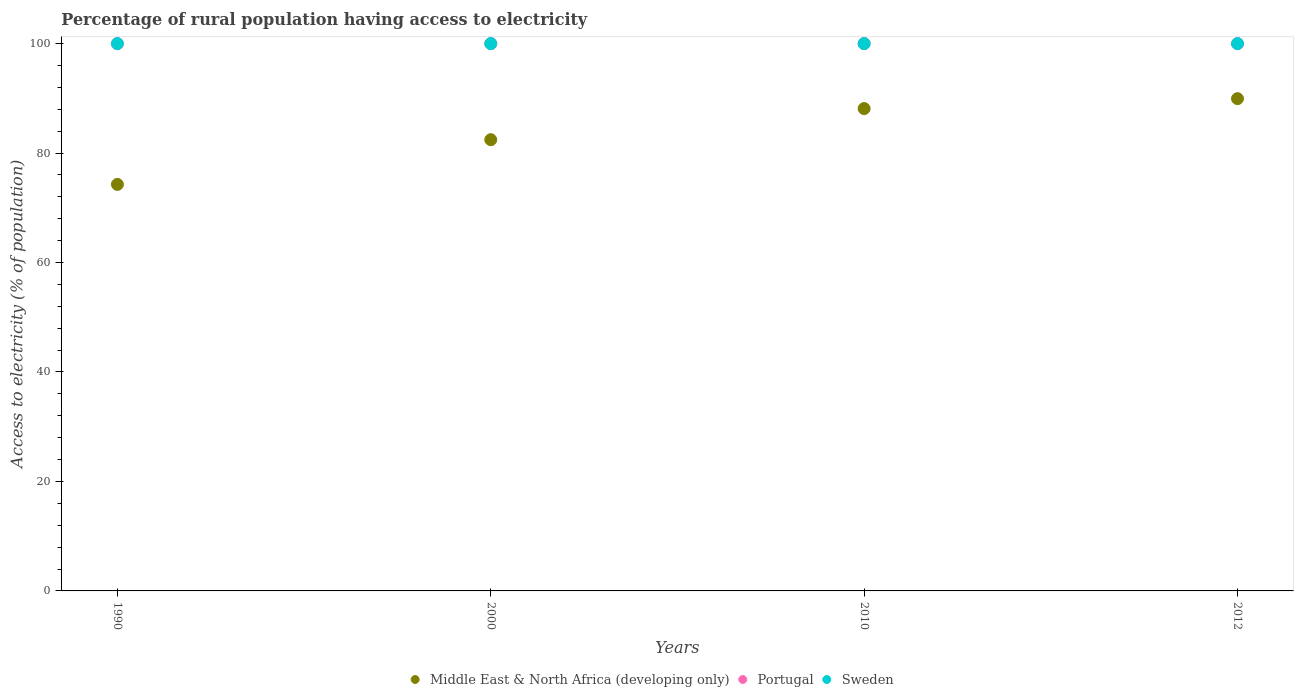Is the number of dotlines equal to the number of legend labels?
Offer a terse response. Yes. What is the percentage of rural population having access to electricity in Portugal in 1990?
Your response must be concise. 100. Across all years, what is the maximum percentage of rural population having access to electricity in Middle East & North Africa (developing only)?
Provide a short and direct response. 89.94. Across all years, what is the minimum percentage of rural population having access to electricity in Sweden?
Provide a short and direct response. 100. In which year was the percentage of rural population having access to electricity in Sweden maximum?
Keep it short and to the point. 1990. In which year was the percentage of rural population having access to electricity in Sweden minimum?
Your answer should be compact. 1990. What is the total percentage of rural population having access to electricity in Sweden in the graph?
Provide a succinct answer. 400. What is the difference between the percentage of rural population having access to electricity in Middle East & North Africa (developing only) in 2000 and that in 2010?
Offer a very short reply. -5.68. What is the difference between the percentage of rural population having access to electricity in Middle East & North Africa (developing only) in 2000 and the percentage of rural population having access to electricity in Portugal in 1990?
Provide a short and direct response. -17.55. In the year 2010, what is the difference between the percentage of rural population having access to electricity in Sweden and percentage of rural population having access to electricity in Portugal?
Provide a succinct answer. 0. In how many years, is the percentage of rural population having access to electricity in Middle East & North Africa (developing only) greater than 48 %?
Your response must be concise. 4. What is the ratio of the percentage of rural population having access to electricity in Portugal in 2000 to that in 2010?
Your response must be concise. 1. Is the percentage of rural population having access to electricity in Middle East & North Africa (developing only) in 2010 less than that in 2012?
Your answer should be compact. Yes. Is the difference between the percentage of rural population having access to electricity in Sweden in 1990 and 2000 greater than the difference between the percentage of rural population having access to electricity in Portugal in 1990 and 2000?
Offer a very short reply. No. What is the difference between the highest and the lowest percentage of rural population having access to electricity in Portugal?
Your answer should be compact. 0. In how many years, is the percentage of rural population having access to electricity in Sweden greater than the average percentage of rural population having access to electricity in Sweden taken over all years?
Offer a very short reply. 0. Is it the case that in every year, the sum of the percentage of rural population having access to electricity in Sweden and percentage of rural population having access to electricity in Middle East & North Africa (developing only)  is greater than the percentage of rural population having access to electricity in Portugal?
Your response must be concise. Yes. Does the percentage of rural population having access to electricity in Sweden monotonically increase over the years?
Keep it short and to the point. No. Is the percentage of rural population having access to electricity in Portugal strictly less than the percentage of rural population having access to electricity in Sweden over the years?
Give a very brief answer. No. What is the difference between two consecutive major ticks on the Y-axis?
Your response must be concise. 20. Does the graph contain grids?
Make the answer very short. No. How many legend labels are there?
Make the answer very short. 3. How are the legend labels stacked?
Your answer should be very brief. Horizontal. What is the title of the graph?
Offer a terse response. Percentage of rural population having access to electricity. What is the label or title of the X-axis?
Keep it short and to the point. Years. What is the label or title of the Y-axis?
Give a very brief answer. Access to electricity (% of population). What is the Access to electricity (% of population) in Middle East & North Africa (developing only) in 1990?
Keep it short and to the point. 74.28. What is the Access to electricity (% of population) of Middle East & North Africa (developing only) in 2000?
Make the answer very short. 82.45. What is the Access to electricity (% of population) of Portugal in 2000?
Keep it short and to the point. 100. What is the Access to electricity (% of population) of Sweden in 2000?
Your answer should be compact. 100. What is the Access to electricity (% of population) of Middle East & North Africa (developing only) in 2010?
Offer a terse response. 88.13. What is the Access to electricity (% of population) of Sweden in 2010?
Your answer should be compact. 100. What is the Access to electricity (% of population) in Middle East & North Africa (developing only) in 2012?
Provide a short and direct response. 89.94. What is the Access to electricity (% of population) in Portugal in 2012?
Your response must be concise. 100. What is the Access to electricity (% of population) in Sweden in 2012?
Offer a very short reply. 100. Across all years, what is the maximum Access to electricity (% of population) in Middle East & North Africa (developing only)?
Provide a succinct answer. 89.94. Across all years, what is the maximum Access to electricity (% of population) in Portugal?
Keep it short and to the point. 100. Across all years, what is the maximum Access to electricity (% of population) of Sweden?
Ensure brevity in your answer.  100. Across all years, what is the minimum Access to electricity (% of population) of Middle East & North Africa (developing only)?
Offer a very short reply. 74.28. Across all years, what is the minimum Access to electricity (% of population) of Sweden?
Ensure brevity in your answer.  100. What is the total Access to electricity (% of population) in Middle East & North Africa (developing only) in the graph?
Your answer should be compact. 334.8. What is the difference between the Access to electricity (% of population) of Middle East & North Africa (developing only) in 1990 and that in 2000?
Ensure brevity in your answer.  -8.17. What is the difference between the Access to electricity (% of population) in Portugal in 1990 and that in 2000?
Your answer should be compact. 0. What is the difference between the Access to electricity (% of population) in Middle East & North Africa (developing only) in 1990 and that in 2010?
Keep it short and to the point. -13.86. What is the difference between the Access to electricity (% of population) in Middle East & North Africa (developing only) in 1990 and that in 2012?
Provide a short and direct response. -15.67. What is the difference between the Access to electricity (% of population) in Middle East & North Africa (developing only) in 2000 and that in 2010?
Provide a succinct answer. -5.68. What is the difference between the Access to electricity (% of population) of Portugal in 2000 and that in 2010?
Provide a short and direct response. 0. What is the difference between the Access to electricity (% of population) in Middle East & North Africa (developing only) in 2000 and that in 2012?
Your answer should be very brief. -7.5. What is the difference between the Access to electricity (% of population) in Portugal in 2000 and that in 2012?
Offer a very short reply. 0. What is the difference between the Access to electricity (% of population) in Middle East & North Africa (developing only) in 2010 and that in 2012?
Offer a very short reply. -1.81. What is the difference between the Access to electricity (% of population) of Sweden in 2010 and that in 2012?
Provide a succinct answer. 0. What is the difference between the Access to electricity (% of population) of Middle East & North Africa (developing only) in 1990 and the Access to electricity (% of population) of Portugal in 2000?
Offer a very short reply. -25.72. What is the difference between the Access to electricity (% of population) in Middle East & North Africa (developing only) in 1990 and the Access to electricity (% of population) in Sweden in 2000?
Provide a succinct answer. -25.72. What is the difference between the Access to electricity (% of population) in Middle East & North Africa (developing only) in 1990 and the Access to electricity (% of population) in Portugal in 2010?
Offer a terse response. -25.72. What is the difference between the Access to electricity (% of population) in Middle East & North Africa (developing only) in 1990 and the Access to electricity (% of population) in Sweden in 2010?
Provide a short and direct response. -25.72. What is the difference between the Access to electricity (% of population) of Middle East & North Africa (developing only) in 1990 and the Access to electricity (% of population) of Portugal in 2012?
Provide a short and direct response. -25.72. What is the difference between the Access to electricity (% of population) of Middle East & North Africa (developing only) in 1990 and the Access to electricity (% of population) of Sweden in 2012?
Offer a very short reply. -25.72. What is the difference between the Access to electricity (% of population) of Portugal in 1990 and the Access to electricity (% of population) of Sweden in 2012?
Offer a very short reply. 0. What is the difference between the Access to electricity (% of population) of Middle East & North Africa (developing only) in 2000 and the Access to electricity (% of population) of Portugal in 2010?
Give a very brief answer. -17.55. What is the difference between the Access to electricity (% of population) of Middle East & North Africa (developing only) in 2000 and the Access to electricity (% of population) of Sweden in 2010?
Provide a succinct answer. -17.55. What is the difference between the Access to electricity (% of population) in Portugal in 2000 and the Access to electricity (% of population) in Sweden in 2010?
Your response must be concise. 0. What is the difference between the Access to electricity (% of population) in Middle East & North Africa (developing only) in 2000 and the Access to electricity (% of population) in Portugal in 2012?
Make the answer very short. -17.55. What is the difference between the Access to electricity (% of population) in Middle East & North Africa (developing only) in 2000 and the Access to electricity (% of population) in Sweden in 2012?
Provide a succinct answer. -17.55. What is the difference between the Access to electricity (% of population) in Middle East & North Africa (developing only) in 2010 and the Access to electricity (% of population) in Portugal in 2012?
Ensure brevity in your answer.  -11.87. What is the difference between the Access to electricity (% of population) in Middle East & North Africa (developing only) in 2010 and the Access to electricity (% of population) in Sweden in 2012?
Your answer should be very brief. -11.87. What is the difference between the Access to electricity (% of population) of Portugal in 2010 and the Access to electricity (% of population) of Sweden in 2012?
Offer a terse response. 0. What is the average Access to electricity (% of population) of Middle East & North Africa (developing only) per year?
Ensure brevity in your answer.  83.7. What is the average Access to electricity (% of population) of Portugal per year?
Your answer should be compact. 100. In the year 1990, what is the difference between the Access to electricity (% of population) of Middle East & North Africa (developing only) and Access to electricity (% of population) of Portugal?
Offer a very short reply. -25.72. In the year 1990, what is the difference between the Access to electricity (% of population) in Middle East & North Africa (developing only) and Access to electricity (% of population) in Sweden?
Offer a terse response. -25.72. In the year 1990, what is the difference between the Access to electricity (% of population) in Portugal and Access to electricity (% of population) in Sweden?
Your answer should be very brief. 0. In the year 2000, what is the difference between the Access to electricity (% of population) in Middle East & North Africa (developing only) and Access to electricity (% of population) in Portugal?
Give a very brief answer. -17.55. In the year 2000, what is the difference between the Access to electricity (% of population) in Middle East & North Africa (developing only) and Access to electricity (% of population) in Sweden?
Your answer should be very brief. -17.55. In the year 2000, what is the difference between the Access to electricity (% of population) of Portugal and Access to electricity (% of population) of Sweden?
Ensure brevity in your answer.  0. In the year 2010, what is the difference between the Access to electricity (% of population) in Middle East & North Africa (developing only) and Access to electricity (% of population) in Portugal?
Your response must be concise. -11.87. In the year 2010, what is the difference between the Access to electricity (% of population) in Middle East & North Africa (developing only) and Access to electricity (% of population) in Sweden?
Offer a very short reply. -11.87. In the year 2010, what is the difference between the Access to electricity (% of population) in Portugal and Access to electricity (% of population) in Sweden?
Offer a very short reply. 0. In the year 2012, what is the difference between the Access to electricity (% of population) of Middle East & North Africa (developing only) and Access to electricity (% of population) of Portugal?
Your answer should be compact. -10.06. In the year 2012, what is the difference between the Access to electricity (% of population) in Middle East & North Africa (developing only) and Access to electricity (% of population) in Sweden?
Offer a very short reply. -10.06. What is the ratio of the Access to electricity (% of population) in Middle East & North Africa (developing only) in 1990 to that in 2000?
Provide a short and direct response. 0.9. What is the ratio of the Access to electricity (% of population) of Sweden in 1990 to that in 2000?
Ensure brevity in your answer.  1. What is the ratio of the Access to electricity (% of population) in Middle East & North Africa (developing only) in 1990 to that in 2010?
Make the answer very short. 0.84. What is the ratio of the Access to electricity (% of population) of Portugal in 1990 to that in 2010?
Give a very brief answer. 1. What is the ratio of the Access to electricity (% of population) in Middle East & North Africa (developing only) in 1990 to that in 2012?
Give a very brief answer. 0.83. What is the ratio of the Access to electricity (% of population) in Portugal in 1990 to that in 2012?
Provide a succinct answer. 1. What is the ratio of the Access to electricity (% of population) of Middle East & North Africa (developing only) in 2000 to that in 2010?
Ensure brevity in your answer.  0.94. What is the ratio of the Access to electricity (% of population) of Sweden in 2000 to that in 2010?
Ensure brevity in your answer.  1. What is the ratio of the Access to electricity (% of population) of Portugal in 2000 to that in 2012?
Provide a short and direct response. 1. What is the ratio of the Access to electricity (% of population) in Sweden in 2000 to that in 2012?
Make the answer very short. 1. What is the ratio of the Access to electricity (% of population) of Middle East & North Africa (developing only) in 2010 to that in 2012?
Offer a very short reply. 0.98. What is the ratio of the Access to electricity (% of population) of Portugal in 2010 to that in 2012?
Your response must be concise. 1. What is the ratio of the Access to electricity (% of population) of Sweden in 2010 to that in 2012?
Make the answer very short. 1. What is the difference between the highest and the second highest Access to electricity (% of population) of Middle East & North Africa (developing only)?
Provide a succinct answer. 1.81. What is the difference between the highest and the second highest Access to electricity (% of population) in Sweden?
Make the answer very short. 0. What is the difference between the highest and the lowest Access to electricity (% of population) of Middle East & North Africa (developing only)?
Make the answer very short. 15.67. 